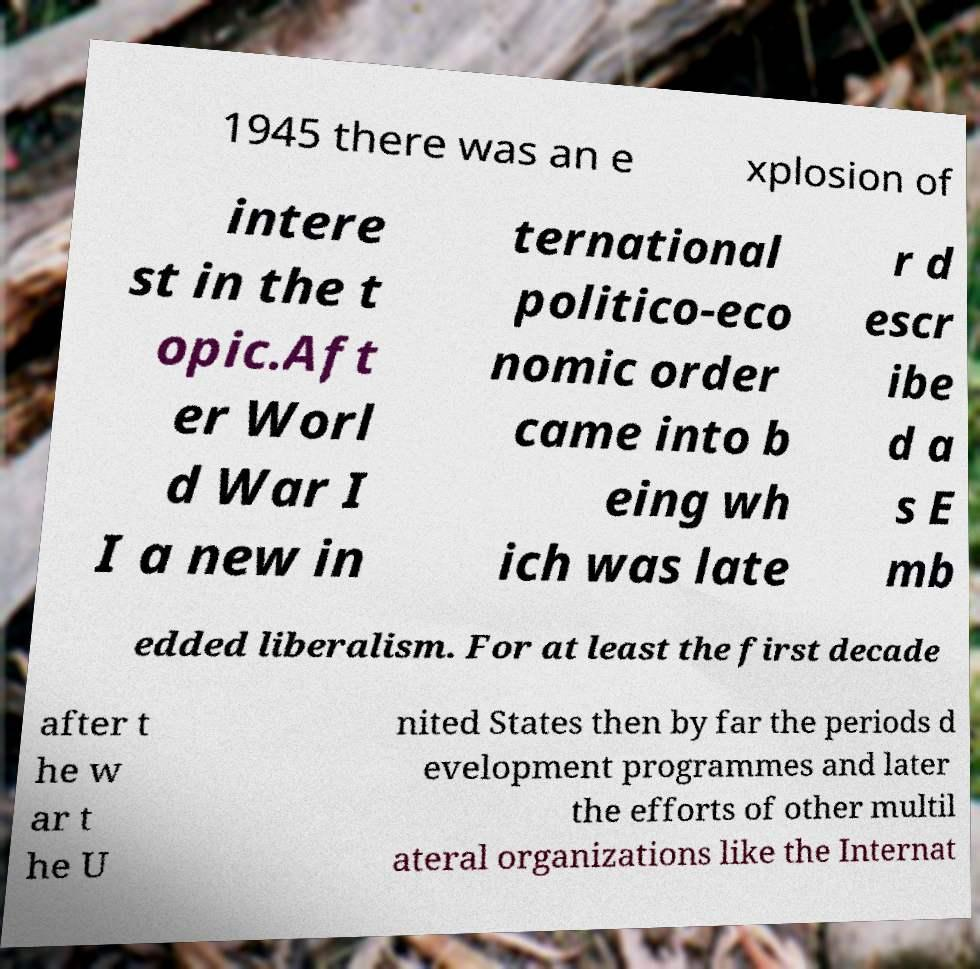Could you extract and type out the text from this image? 1945 there was an e xplosion of intere st in the t opic.Aft er Worl d War I I a new in ternational politico-eco nomic order came into b eing wh ich was late r d escr ibe d a s E mb edded liberalism. For at least the first decade after t he w ar t he U nited States then by far the periods d evelopment programmes and later the efforts of other multil ateral organizations like the Internat 